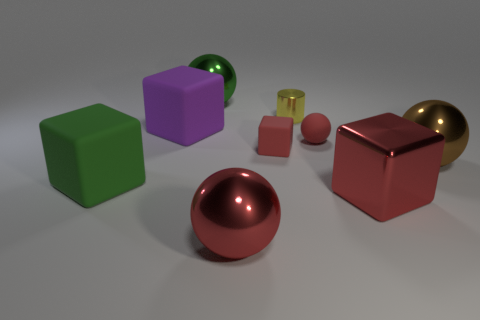There is a sphere to the right of the big red shiny thing that is behind the big red metal thing that is left of the tiny red block; what is its color? brown 